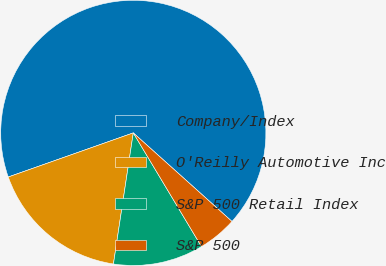Convert chart to OTSL. <chart><loc_0><loc_0><loc_500><loc_500><pie_chart><fcel>Company/Index<fcel>O'Reilly Automotive Inc<fcel>S&P 500 Retail Index<fcel>S&P 500<nl><fcel>67.04%<fcel>17.21%<fcel>10.99%<fcel>4.76%<nl></chart> 